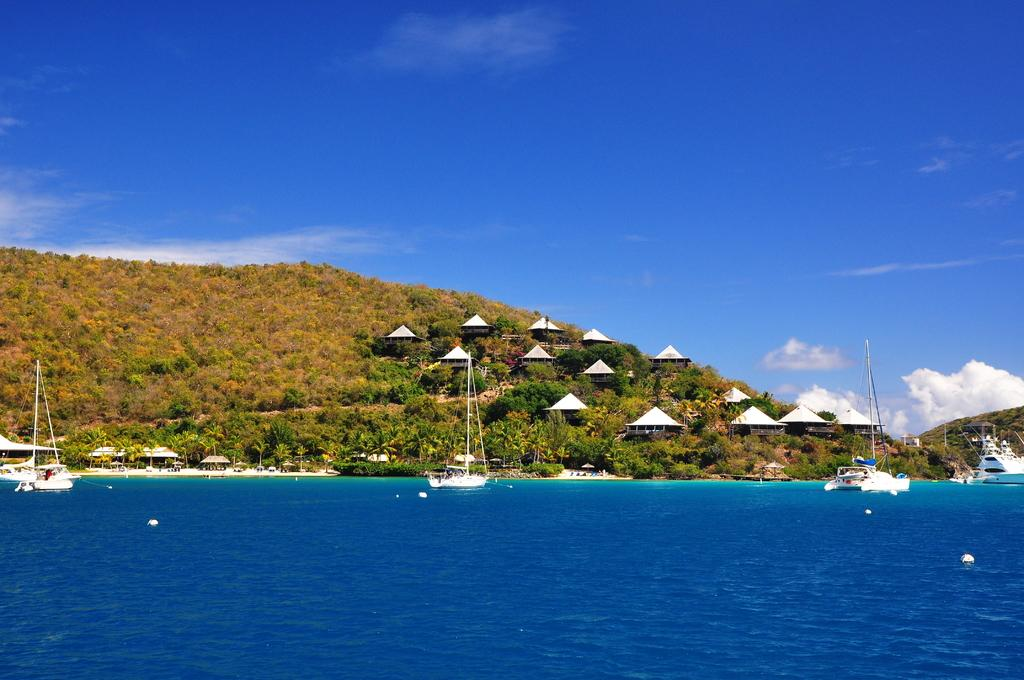What is floating on the water in the image? There are boats floating on the water in the image. What can be seen in the middle of the image? There is a hill in the middle of the image. What is visible at the top of the image? The sky is visible at the top of the image. Where are the icicles hanging in the image? There are no icicles present in the image. What type of cart is visible on the hill in the image? There is no cart present in the image; only boats, water, a hill, and the sky are visible. 